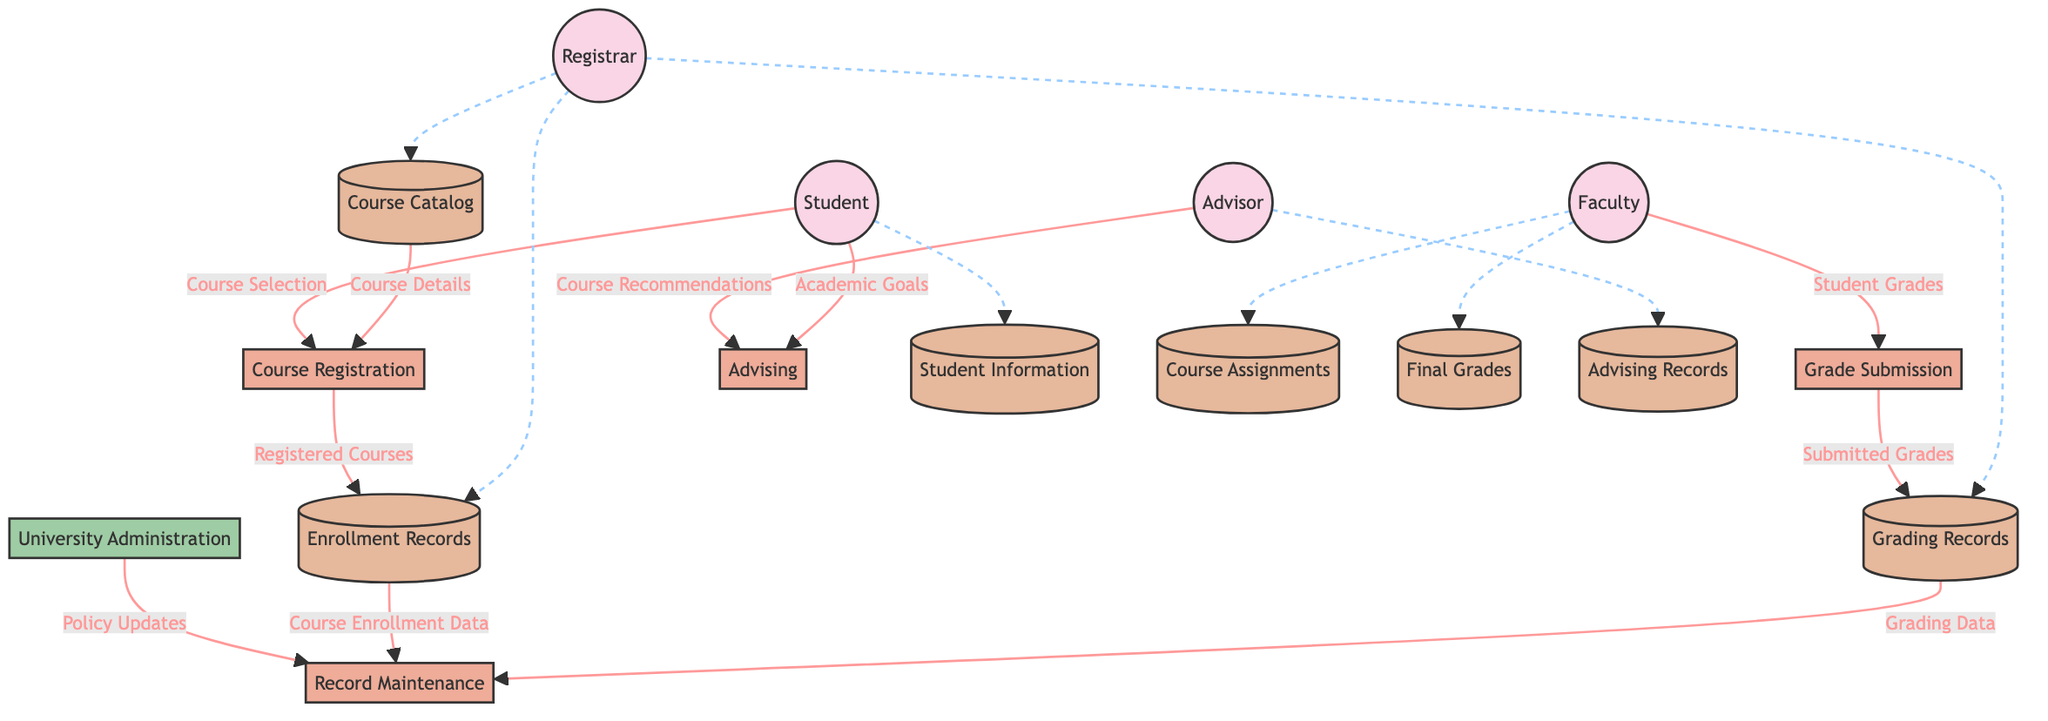What is the main process for students to register for courses? The diagram indicates that the main process by which students register for courses is labeled as "Course Registration."
Answer: Course Registration How many entities are involved in this system? By counting the entities shown in the diagram, there are four entities: Student, Registrar, Faculty, and Advisor.
Answer: Four What type of records does the Registrar maintain? The Registrar maintains records related to "Enrollment Records" and "Grading Records" as represented in the relevant data store sections of the diagram.
Answer: Enrollment Records and Grading Records Who submits grades for students? The diagram shows that grades are submitted by the "Faculty" through the process labeled "Grade Submission."
Answer: Faculty What data flow comes from the University Administration to Record Maintenance? According to the diagram, "Policy Updates" flow from the University Administration to the Record Maintenance process.
Answer: Policy Updates Which data store contains detailed student information? The data store named "Student Information" contains detailed information about each student, as indicated in the diagram's data store section.
Answer: Student Information What does the Advisor provide in the Advising process? The Advisor provides "Course Recommendations" in the Advising process, as derived from the data flow outlined in the diagram.
Answer: Course Recommendations What happens to student grades after they are submitted? After grades are submitted by faculty, they are directed to the "Grading Records" data store, according to the flow shown in the diagram.
Answer: Grading Records How does a student interact with the Advising process? The diagram illustrates that students interact with the Advising process by providing their "Academic Goals" and receiving "Course Recommendations."
Answer: Academic Goals What flows from Enrollment Records to Record Maintenance? The data flow labeled "Course Enrollment Data" moves from the Enrollment Records to the Record Maintenance process, as shown in the diagram.
Answer: Course Enrollment Data 